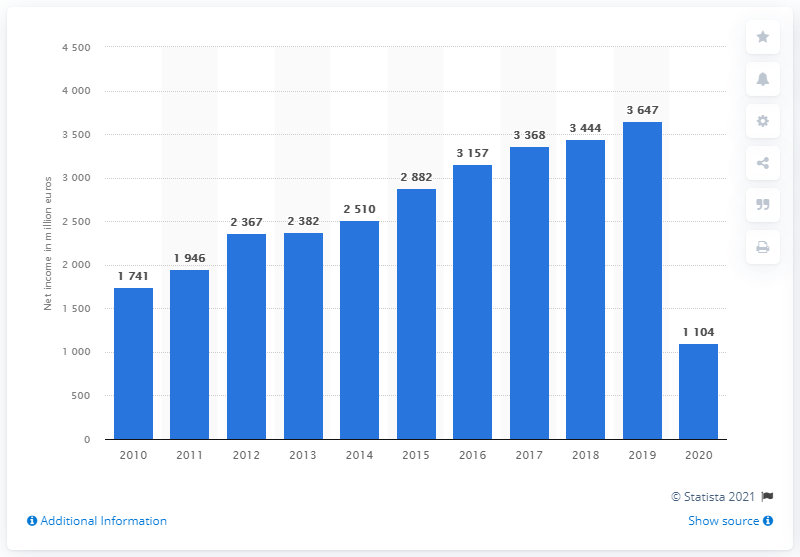Outline some significant characteristics in this image. In 2010, the global net income of the Inditex Group was 1104. 